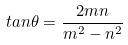Convert formula to latex. <formula><loc_0><loc_0><loc_500><loc_500>t a n \theta = \frac { 2 m n } { m ^ { 2 } - n ^ { 2 } }</formula> 